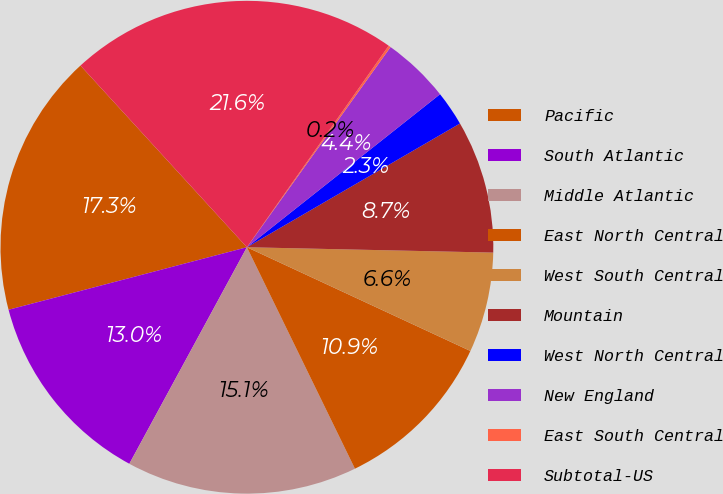Convert chart. <chart><loc_0><loc_0><loc_500><loc_500><pie_chart><fcel>Pacific<fcel>South Atlantic<fcel>Middle Atlantic<fcel>East North Central<fcel>West South Central<fcel>Mountain<fcel>West North Central<fcel>New England<fcel>East South Central<fcel>Subtotal-US<nl><fcel>17.28%<fcel>13.0%<fcel>15.14%<fcel>10.86%<fcel>6.57%<fcel>8.72%<fcel>2.29%<fcel>4.43%<fcel>0.15%<fcel>21.56%<nl></chart> 